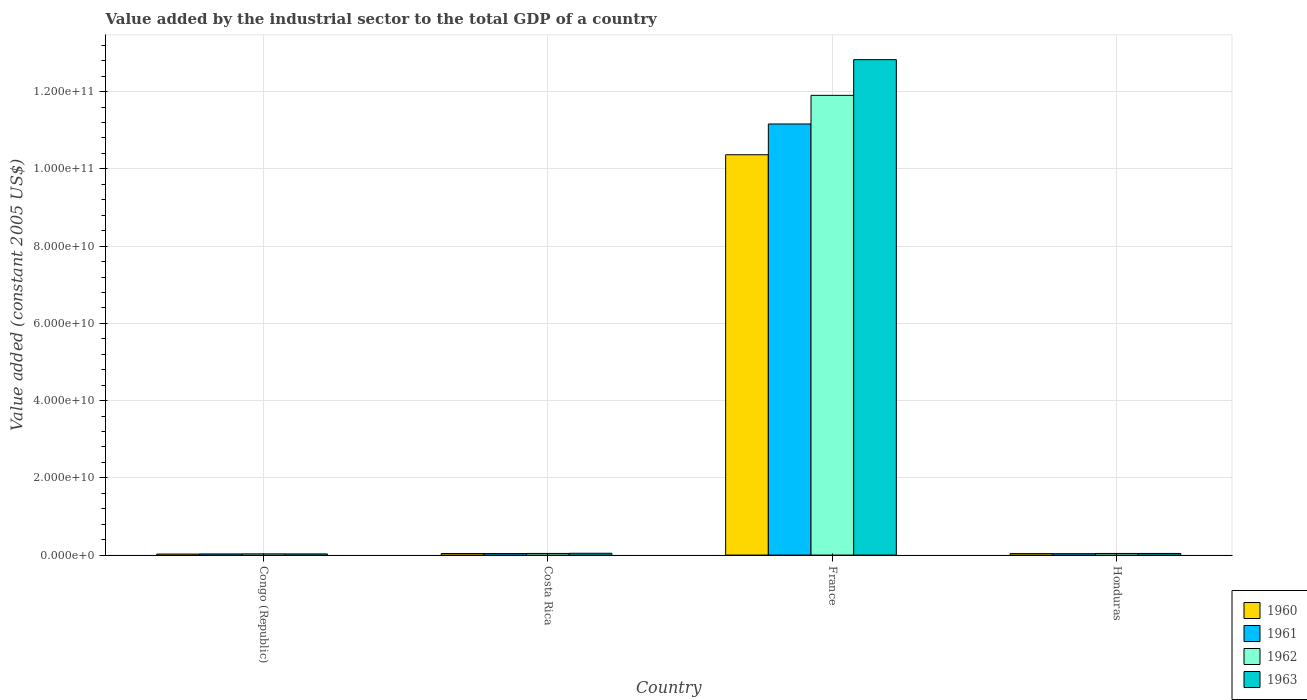What is the label of the 4th group of bars from the left?
Offer a terse response. Honduras. In how many cases, is the number of bars for a given country not equal to the number of legend labels?
Offer a very short reply. 0. What is the value added by the industrial sector in 1962 in Costa Rica?
Give a very brief answer. 4.27e+08. Across all countries, what is the maximum value added by the industrial sector in 1960?
Make the answer very short. 1.04e+11. Across all countries, what is the minimum value added by the industrial sector in 1960?
Make the answer very short. 2.61e+08. In which country was the value added by the industrial sector in 1963 minimum?
Ensure brevity in your answer.  Congo (Republic). What is the total value added by the industrial sector in 1960 in the graph?
Offer a very short reply. 1.05e+11. What is the difference between the value added by the industrial sector in 1962 in France and that in Honduras?
Provide a succinct answer. 1.19e+11. What is the difference between the value added by the industrial sector in 1963 in Congo (Republic) and the value added by the industrial sector in 1962 in France?
Make the answer very short. -1.19e+11. What is the average value added by the industrial sector in 1960 per country?
Offer a terse response. 2.62e+1. What is the difference between the value added by the industrial sector of/in 1961 and value added by the industrial sector of/in 1960 in France?
Make the answer very short. 7.97e+09. What is the ratio of the value added by the industrial sector in 1960 in Congo (Republic) to that in Honduras?
Provide a short and direct response. 0.7. Is the difference between the value added by the industrial sector in 1961 in Costa Rica and France greater than the difference between the value added by the industrial sector in 1960 in Costa Rica and France?
Your answer should be very brief. No. What is the difference between the highest and the second highest value added by the industrial sector in 1962?
Your answer should be compact. 1.19e+11. What is the difference between the highest and the lowest value added by the industrial sector in 1960?
Give a very brief answer. 1.03e+11. In how many countries, is the value added by the industrial sector in 1963 greater than the average value added by the industrial sector in 1963 taken over all countries?
Offer a terse response. 1. Is it the case that in every country, the sum of the value added by the industrial sector in 1961 and value added by the industrial sector in 1962 is greater than the sum of value added by the industrial sector in 1963 and value added by the industrial sector in 1960?
Provide a short and direct response. No. Is it the case that in every country, the sum of the value added by the industrial sector in 1963 and value added by the industrial sector in 1962 is greater than the value added by the industrial sector in 1961?
Your response must be concise. Yes. How many bars are there?
Ensure brevity in your answer.  16. What is the difference between two consecutive major ticks on the Y-axis?
Your answer should be very brief. 2.00e+1. Does the graph contain grids?
Your response must be concise. Yes. Where does the legend appear in the graph?
Make the answer very short. Bottom right. How many legend labels are there?
Provide a succinct answer. 4. What is the title of the graph?
Give a very brief answer. Value added by the industrial sector to the total GDP of a country. What is the label or title of the Y-axis?
Give a very brief answer. Value added (constant 2005 US$). What is the Value added (constant 2005 US$) in 1960 in Congo (Republic)?
Your answer should be compact. 2.61e+08. What is the Value added (constant 2005 US$) in 1961 in Congo (Republic)?
Your answer should be very brief. 2.98e+08. What is the Value added (constant 2005 US$) of 1962 in Congo (Republic)?
Ensure brevity in your answer.  3.12e+08. What is the Value added (constant 2005 US$) of 1963 in Congo (Republic)?
Your answer should be very brief. 3.00e+08. What is the Value added (constant 2005 US$) of 1960 in Costa Rica?
Offer a very short reply. 3.98e+08. What is the Value added (constant 2005 US$) in 1961 in Costa Rica?
Keep it short and to the point. 3.94e+08. What is the Value added (constant 2005 US$) of 1962 in Costa Rica?
Offer a very short reply. 4.27e+08. What is the Value added (constant 2005 US$) of 1963 in Costa Rica?
Keep it short and to the point. 4.68e+08. What is the Value added (constant 2005 US$) of 1960 in France?
Keep it short and to the point. 1.04e+11. What is the Value added (constant 2005 US$) of 1961 in France?
Give a very brief answer. 1.12e+11. What is the Value added (constant 2005 US$) of 1962 in France?
Offer a very short reply. 1.19e+11. What is the Value added (constant 2005 US$) in 1963 in France?
Your answer should be very brief. 1.28e+11. What is the Value added (constant 2005 US$) of 1960 in Honduras?
Your answer should be compact. 3.75e+08. What is the Value added (constant 2005 US$) in 1961 in Honduras?
Offer a very short reply. 3.66e+08. What is the Value added (constant 2005 US$) in 1962 in Honduras?
Your response must be concise. 4.16e+08. What is the Value added (constant 2005 US$) of 1963 in Honduras?
Your answer should be compact. 4.23e+08. Across all countries, what is the maximum Value added (constant 2005 US$) of 1960?
Make the answer very short. 1.04e+11. Across all countries, what is the maximum Value added (constant 2005 US$) in 1961?
Ensure brevity in your answer.  1.12e+11. Across all countries, what is the maximum Value added (constant 2005 US$) of 1962?
Your answer should be compact. 1.19e+11. Across all countries, what is the maximum Value added (constant 2005 US$) in 1963?
Keep it short and to the point. 1.28e+11. Across all countries, what is the minimum Value added (constant 2005 US$) of 1960?
Offer a very short reply. 2.61e+08. Across all countries, what is the minimum Value added (constant 2005 US$) of 1961?
Your answer should be very brief. 2.98e+08. Across all countries, what is the minimum Value added (constant 2005 US$) in 1962?
Make the answer very short. 3.12e+08. Across all countries, what is the minimum Value added (constant 2005 US$) of 1963?
Your answer should be very brief. 3.00e+08. What is the total Value added (constant 2005 US$) of 1960 in the graph?
Make the answer very short. 1.05e+11. What is the total Value added (constant 2005 US$) in 1961 in the graph?
Your answer should be compact. 1.13e+11. What is the total Value added (constant 2005 US$) of 1962 in the graph?
Give a very brief answer. 1.20e+11. What is the total Value added (constant 2005 US$) in 1963 in the graph?
Give a very brief answer. 1.29e+11. What is the difference between the Value added (constant 2005 US$) of 1960 in Congo (Republic) and that in Costa Rica?
Ensure brevity in your answer.  -1.36e+08. What is the difference between the Value added (constant 2005 US$) in 1961 in Congo (Republic) and that in Costa Rica?
Make the answer very short. -9.59e+07. What is the difference between the Value added (constant 2005 US$) in 1962 in Congo (Republic) and that in Costa Rica?
Give a very brief answer. -1.14e+08. What is the difference between the Value added (constant 2005 US$) in 1963 in Congo (Republic) and that in Costa Rica?
Keep it short and to the point. -1.68e+08. What is the difference between the Value added (constant 2005 US$) of 1960 in Congo (Republic) and that in France?
Your response must be concise. -1.03e+11. What is the difference between the Value added (constant 2005 US$) of 1961 in Congo (Republic) and that in France?
Your answer should be very brief. -1.11e+11. What is the difference between the Value added (constant 2005 US$) in 1962 in Congo (Republic) and that in France?
Provide a succinct answer. -1.19e+11. What is the difference between the Value added (constant 2005 US$) in 1963 in Congo (Republic) and that in France?
Offer a very short reply. -1.28e+11. What is the difference between the Value added (constant 2005 US$) of 1960 in Congo (Republic) and that in Honduras?
Make the answer very short. -1.14e+08. What is the difference between the Value added (constant 2005 US$) of 1961 in Congo (Republic) and that in Honduras?
Ensure brevity in your answer.  -6.81e+07. What is the difference between the Value added (constant 2005 US$) of 1962 in Congo (Republic) and that in Honduras?
Ensure brevity in your answer.  -1.03e+08. What is the difference between the Value added (constant 2005 US$) in 1963 in Congo (Republic) and that in Honduras?
Ensure brevity in your answer.  -1.23e+08. What is the difference between the Value added (constant 2005 US$) of 1960 in Costa Rica and that in France?
Offer a terse response. -1.03e+11. What is the difference between the Value added (constant 2005 US$) of 1961 in Costa Rica and that in France?
Provide a short and direct response. -1.11e+11. What is the difference between the Value added (constant 2005 US$) in 1962 in Costa Rica and that in France?
Make the answer very short. -1.19e+11. What is the difference between the Value added (constant 2005 US$) in 1963 in Costa Rica and that in France?
Keep it short and to the point. -1.28e+11. What is the difference between the Value added (constant 2005 US$) of 1960 in Costa Rica and that in Honduras?
Keep it short and to the point. 2.26e+07. What is the difference between the Value added (constant 2005 US$) in 1961 in Costa Rica and that in Honduras?
Keep it short and to the point. 2.78e+07. What is the difference between the Value added (constant 2005 US$) of 1962 in Costa Rica and that in Honduras?
Your answer should be very brief. 1.10e+07. What is the difference between the Value added (constant 2005 US$) of 1963 in Costa Rica and that in Honduras?
Your response must be concise. 4.49e+07. What is the difference between the Value added (constant 2005 US$) in 1960 in France and that in Honduras?
Offer a very short reply. 1.03e+11. What is the difference between the Value added (constant 2005 US$) in 1961 in France and that in Honduras?
Make the answer very short. 1.11e+11. What is the difference between the Value added (constant 2005 US$) in 1962 in France and that in Honduras?
Provide a succinct answer. 1.19e+11. What is the difference between the Value added (constant 2005 US$) in 1963 in France and that in Honduras?
Your response must be concise. 1.28e+11. What is the difference between the Value added (constant 2005 US$) in 1960 in Congo (Republic) and the Value added (constant 2005 US$) in 1961 in Costa Rica?
Provide a succinct answer. -1.32e+08. What is the difference between the Value added (constant 2005 US$) in 1960 in Congo (Republic) and the Value added (constant 2005 US$) in 1962 in Costa Rica?
Provide a short and direct response. -1.65e+08. What is the difference between the Value added (constant 2005 US$) of 1960 in Congo (Republic) and the Value added (constant 2005 US$) of 1963 in Costa Rica?
Ensure brevity in your answer.  -2.07e+08. What is the difference between the Value added (constant 2005 US$) in 1961 in Congo (Republic) and the Value added (constant 2005 US$) in 1962 in Costa Rica?
Offer a very short reply. -1.29e+08. What is the difference between the Value added (constant 2005 US$) in 1961 in Congo (Republic) and the Value added (constant 2005 US$) in 1963 in Costa Rica?
Make the answer very short. -1.70e+08. What is the difference between the Value added (constant 2005 US$) of 1962 in Congo (Republic) and the Value added (constant 2005 US$) of 1963 in Costa Rica?
Your response must be concise. -1.56e+08. What is the difference between the Value added (constant 2005 US$) in 1960 in Congo (Republic) and the Value added (constant 2005 US$) in 1961 in France?
Your answer should be compact. -1.11e+11. What is the difference between the Value added (constant 2005 US$) of 1960 in Congo (Republic) and the Value added (constant 2005 US$) of 1962 in France?
Provide a short and direct response. -1.19e+11. What is the difference between the Value added (constant 2005 US$) in 1960 in Congo (Republic) and the Value added (constant 2005 US$) in 1963 in France?
Give a very brief answer. -1.28e+11. What is the difference between the Value added (constant 2005 US$) of 1961 in Congo (Republic) and the Value added (constant 2005 US$) of 1962 in France?
Offer a very short reply. -1.19e+11. What is the difference between the Value added (constant 2005 US$) of 1961 in Congo (Republic) and the Value added (constant 2005 US$) of 1963 in France?
Give a very brief answer. -1.28e+11. What is the difference between the Value added (constant 2005 US$) in 1962 in Congo (Republic) and the Value added (constant 2005 US$) in 1963 in France?
Give a very brief answer. -1.28e+11. What is the difference between the Value added (constant 2005 US$) in 1960 in Congo (Republic) and the Value added (constant 2005 US$) in 1961 in Honduras?
Give a very brief answer. -1.04e+08. What is the difference between the Value added (constant 2005 US$) in 1960 in Congo (Republic) and the Value added (constant 2005 US$) in 1962 in Honduras?
Offer a very short reply. -1.54e+08. What is the difference between the Value added (constant 2005 US$) of 1960 in Congo (Republic) and the Value added (constant 2005 US$) of 1963 in Honduras?
Keep it short and to the point. -1.62e+08. What is the difference between the Value added (constant 2005 US$) in 1961 in Congo (Republic) and the Value added (constant 2005 US$) in 1962 in Honduras?
Make the answer very short. -1.18e+08. What is the difference between the Value added (constant 2005 US$) in 1961 in Congo (Republic) and the Value added (constant 2005 US$) in 1963 in Honduras?
Your answer should be very brief. -1.25e+08. What is the difference between the Value added (constant 2005 US$) in 1962 in Congo (Republic) and the Value added (constant 2005 US$) in 1963 in Honduras?
Your answer should be compact. -1.11e+08. What is the difference between the Value added (constant 2005 US$) of 1960 in Costa Rica and the Value added (constant 2005 US$) of 1961 in France?
Offer a terse response. -1.11e+11. What is the difference between the Value added (constant 2005 US$) in 1960 in Costa Rica and the Value added (constant 2005 US$) in 1962 in France?
Ensure brevity in your answer.  -1.19e+11. What is the difference between the Value added (constant 2005 US$) of 1960 in Costa Rica and the Value added (constant 2005 US$) of 1963 in France?
Keep it short and to the point. -1.28e+11. What is the difference between the Value added (constant 2005 US$) in 1961 in Costa Rica and the Value added (constant 2005 US$) in 1962 in France?
Provide a succinct answer. -1.19e+11. What is the difference between the Value added (constant 2005 US$) in 1961 in Costa Rica and the Value added (constant 2005 US$) in 1963 in France?
Offer a terse response. -1.28e+11. What is the difference between the Value added (constant 2005 US$) of 1962 in Costa Rica and the Value added (constant 2005 US$) of 1963 in France?
Give a very brief answer. -1.28e+11. What is the difference between the Value added (constant 2005 US$) of 1960 in Costa Rica and the Value added (constant 2005 US$) of 1961 in Honduras?
Give a very brief answer. 3.20e+07. What is the difference between the Value added (constant 2005 US$) in 1960 in Costa Rica and the Value added (constant 2005 US$) in 1962 in Honduras?
Your answer should be very brief. -1.81e+07. What is the difference between the Value added (constant 2005 US$) of 1960 in Costa Rica and the Value added (constant 2005 US$) of 1963 in Honduras?
Your response must be concise. -2.52e+07. What is the difference between the Value added (constant 2005 US$) of 1961 in Costa Rica and the Value added (constant 2005 US$) of 1962 in Honduras?
Your response must be concise. -2.22e+07. What is the difference between the Value added (constant 2005 US$) of 1961 in Costa Rica and the Value added (constant 2005 US$) of 1963 in Honduras?
Provide a short and direct response. -2.94e+07. What is the difference between the Value added (constant 2005 US$) of 1962 in Costa Rica and the Value added (constant 2005 US$) of 1963 in Honduras?
Make the answer very short. 3.81e+06. What is the difference between the Value added (constant 2005 US$) of 1960 in France and the Value added (constant 2005 US$) of 1961 in Honduras?
Ensure brevity in your answer.  1.03e+11. What is the difference between the Value added (constant 2005 US$) in 1960 in France and the Value added (constant 2005 US$) in 1962 in Honduras?
Provide a succinct answer. 1.03e+11. What is the difference between the Value added (constant 2005 US$) of 1960 in France and the Value added (constant 2005 US$) of 1963 in Honduras?
Give a very brief answer. 1.03e+11. What is the difference between the Value added (constant 2005 US$) of 1961 in France and the Value added (constant 2005 US$) of 1962 in Honduras?
Provide a short and direct response. 1.11e+11. What is the difference between the Value added (constant 2005 US$) in 1961 in France and the Value added (constant 2005 US$) in 1963 in Honduras?
Keep it short and to the point. 1.11e+11. What is the difference between the Value added (constant 2005 US$) of 1962 in France and the Value added (constant 2005 US$) of 1963 in Honduras?
Keep it short and to the point. 1.19e+11. What is the average Value added (constant 2005 US$) of 1960 per country?
Your answer should be compact. 2.62e+1. What is the average Value added (constant 2005 US$) of 1961 per country?
Ensure brevity in your answer.  2.82e+1. What is the average Value added (constant 2005 US$) in 1962 per country?
Provide a succinct answer. 3.00e+1. What is the average Value added (constant 2005 US$) of 1963 per country?
Ensure brevity in your answer.  3.24e+1. What is the difference between the Value added (constant 2005 US$) of 1960 and Value added (constant 2005 US$) of 1961 in Congo (Republic)?
Provide a short and direct response. -3.63e+07. What is the difference between the Value added (constant 2005 US$) in 1960 and Value added (constant 2005 US$) in 1962 in Congo (Republic)?
Offer a very short reply. -5.10e+07. What is the difference between the Value added (constant 2005 US$) of 1960 and Value added (constant 2005 US$) of 1963 in Congo (Republic)?
Offer a terse response. -3.84e+07. What is the difference between the Value added (constant 2005 US$) of 1961 and Value added (constant 2005 US$) of 1962 in Congo (Republic)?
Offer a very short reply. -1.47e+07. What is the difference between the Value added (constant 2005 US$) of 1961 and Value added (constant 2005 US$) of 1963 in Congo (Republic)?
Ensure brevity in your answer.  -2.10e+06. What is the difference between the Value added (constant 2005 US$) in 1962 and Value added (constant 2005 US$) in 1963 in Congo (Republic)?
Make the answer very short. 1.26e+07. What is the difference between the Value added (constant 2005 US$) in 1960 and Value added (constant 2005 US$) in 1961 in Costa Rica?
Give a very brief answer. 4.19e+06. What is the difference between the Value added (constant 2005 US$) of 1960 and Value added (constant 2005 US$) of 1962 in Costa Rica?
Give a very brief answer. -2.91e+07. What is the difference between the Value added (constant 2005 US$) of 1960 and Value added (constant 2005 US$) of 1963 in Costa Rica?
Give a very brief answer. -7.01e+07. What is the difference between the Value added (constant 2005 US$) in 1961 and Value added (constant 2005 US$) in 1962 in Costa Rica?
Provide a succinct answer. -3.32e+07. What is the difference between the Value added (constant 2005 US$) in 1961 and Value added (constant 2005 US$) in 1963 in Costa Rica?
Offer a very short reply. -7.43e+07. What is the difference between the Value added (constant 2005 US$) of 1962 and Value added (constant 2005 US$) of 1963 in Costa Rica?
Give a very brief answer. -4.11e+07. What is the difference between the Value added (constant 2005 US$) of 1960 and Value added (constant 2005 US$) of 1961 in France?
Your answer should be compact. -7.97e+09. What is the difference between the Value added (constant 2005 US$) of 1960 and Value added (constant 2005 US$) of 1962 in France?
Keep it short and to the point. -1.54e+1. What is the difference between the Value added (constant 2005 US$) of 1960 and Value added (constant 2005 US$) of 1963 in France?
Your answer should be very brief. -2.46e+1. What is the difference between the Value added (constant 2005 US$) of 1961 and Value added (constant 2005 US$) of 1962 in France?
Offer a terse response. -7.41e+09. What is the difference between the Value added (constant 2005 US$) in 1961 and Value added (constant 2005 US$) in 1963 in France?
Ensure brevity in your answer.  -1.67e+1. What is the difference between the Value added (constant 2005 US$) in 1962 and Value added (constant 2005 US$) in 1963 in France?
Your answer should be compact. -9.25e+09. What is the difference between the Value added (constant 2005 US$) of 1960 and Value added (constant 2005 US$) of 1961 in Honduras?
Offer a terse response. 9.37e+06. What is the difference between the Value added (constant 2005 US$) of 1960 and Value added (constant 2005 US$) of 1962 in Honduras?
Keep it short and to the point. -4.07e+07. What is the difference between the Value added (constant 2005 US$) of 1960 and Value added (constant 2005 US$) of 1963 in Honduras?
Your answer should be very brief. -4.79e+07. What is the difference between the Value added (constant 2005 US$) of 1961 and Value added (constant 2005 US$) of 1962 in Honduras?
Offer a very short reply. -5.00e+07. What is the difference between the Value added (constant 2005 US$) of 1961 and Value added (constant 2005 US$) of 1963 in Honduras?
Ensure brevity in your answer.  -5.72e+07. What is the difference between the Value added (constant 2005 US$) in 1962 and Value added (constant 2005 US$) in 1963 in Honduras?
Give a very brief answer. -7.19e+06. What is the ratio of the Value added (constant 2005 US$) of 1960 in Congo (Republic) to that in Costa Rica?
Ensure brevity in your answer.  0.66. What is the ratio of the Value added (constant 2005 US$) of 1961 in Congo (Republic) to that in Costa Rica?
Provide a short and direct response. 0.76. What is the ratio of the Value added (constant 2005 US$) of 1962 in Congo (Republic) to that in Costa Rica?
Offer a terse response. 0.73. What is the ratio of the Value added (constant 2005 US$) of 1963 in Congo (Republic) to that in Costa Rica?
Keep it short and to the point. 0.64. What is the ratio of the Value added (constant 2005 US$) in 1960 in Congo (Republic) to that in France?
Offer a very short reply. 0. What is the ratio of the Value added (constant 2005 US$) in 1961 in Congo (Republic) to that in France?
Your answer should be very brief. 0. What is the ratio of the Value added (constant 2005 US$) in 1962 in Congo (Republic) to that in France?
Ensure brevity in your answer.  0. What is the ratio of the Value added (constant 2005 US$) in 1963 in Congo (Republic) to that in France?
Make the answer very short. 0. What is the ratio of the Value added (constant 2005 US$) in 1960 in Congo (Republic) to that in Honduras?
Offer a terse response. 0.7. What is the ratio of the Value added (constant 2005 US$) in 1961 in Congo (Republic) to that in Honduras?
Offer a very short reply. 0.81. What is the ratio of the Value added (constant 2005 US$) of 1962 in Congo (Republic) to that in Honduras?
Give a very brief answer. 0.75. What is the ratio of the Value added (constant 2005 US$) of 1963 in Congo (Republic) to that in Honduras?
Provide a succinct answer. 0.71. What is the ratio of the Value added (constant 2005 US$) of 1960 in Costa Rica to that in France?
Your response must be concise. 0. What is the ratio of the Value added (constant 2005 US$) in 1961 in Costa Rica to that in France?
Offer a very short reply. 0. What is the ratio of the Value added (constant 2005 US$) of 1962 in Costa Rica to that in France?
Offer a terse response. 0. What is the ratio of the Value added (constant 2005 US$) in 1963 in Costa Rica to that in France?
Offer a very short reply. 0. What is the ratio of the Value added (constant 2005 US$) of 1960 in Costa Rica to that in Honduras?
Keep it short and to the point. 1.06. What is the ratio of the Value added (constant 2005 US$) in 1961 in Costa Rica to that in Honduras?
Your answer should be compact. 1.08. What is the ratio of the Value added (constant 2005 US$) of 1962 in Costa Rica to that in Honduras?
Your answer should be very brief. 1.03. What is the ratio of the Value added (constant 2005 US$) of 1963 in Costa Rica to that in Honduras?
Provide a succinct answer. 1.11. What is the ratio of the Value added (constant 2005 US$) of 1960 in France to that in Honduras?
Your response must be concise. 276.31. What is the ratio of the Value added (constant 2005 US$) in 1961 in France to that in Honduras?
Give a very brief answer. 305.16. What is the ratio of the Value added (constant 2005 US$) of 1962 in France to that in Honduras?
Ensure brevity in your answer.  286.26. What is the ratio of the Value added (constant 2005 US$) of 1963 in France to that in Honduras?
Your answer should be compact. 303.25. What is the difference between the highest and the second highest Value added (constant 2005 US$) of 1960?
Give a very brief answer. 1.03e+11. What is the difference between the highest and the second highest Value added (constant 2005 US$) of 1961?
Offer a terse response. 1.11e+11. What is the difference between the highest and the second highest Value added (constant 2005 US$) in 1962?
Keep it short and to the point. 1.19e+11. What is the difference between the highest and the second highest Value added (constant 2005 US$) in 1963?
Offer a terse response. 1.28e+11. What is the difference between the highest and the lowest Value added (constant 2005 US$) in 1960?
Give a very brief answer. 1.03e+11. What is the difference between the highest and the lowest Value added (constant 2005 US$) of 1961?
Offer a very short reply. 1.11e+11. What is the difference between the highest and the lowest Value added (constant 2005 US$) of 1962?
Your answer should be compact. 1.19e+11. What is the difference between the highest and the lowest Value added (constant 2005 US$) of 1963?
Offer a very short reply. 1.28e+11. 